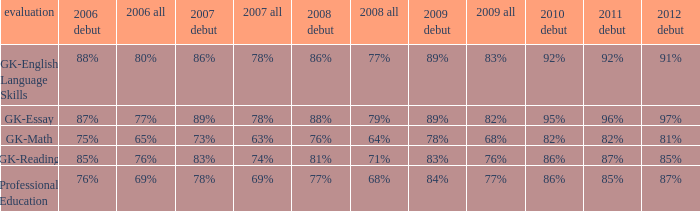What is the percentage for first time in 2012 when it was 82% for all in 2009? 97%. 